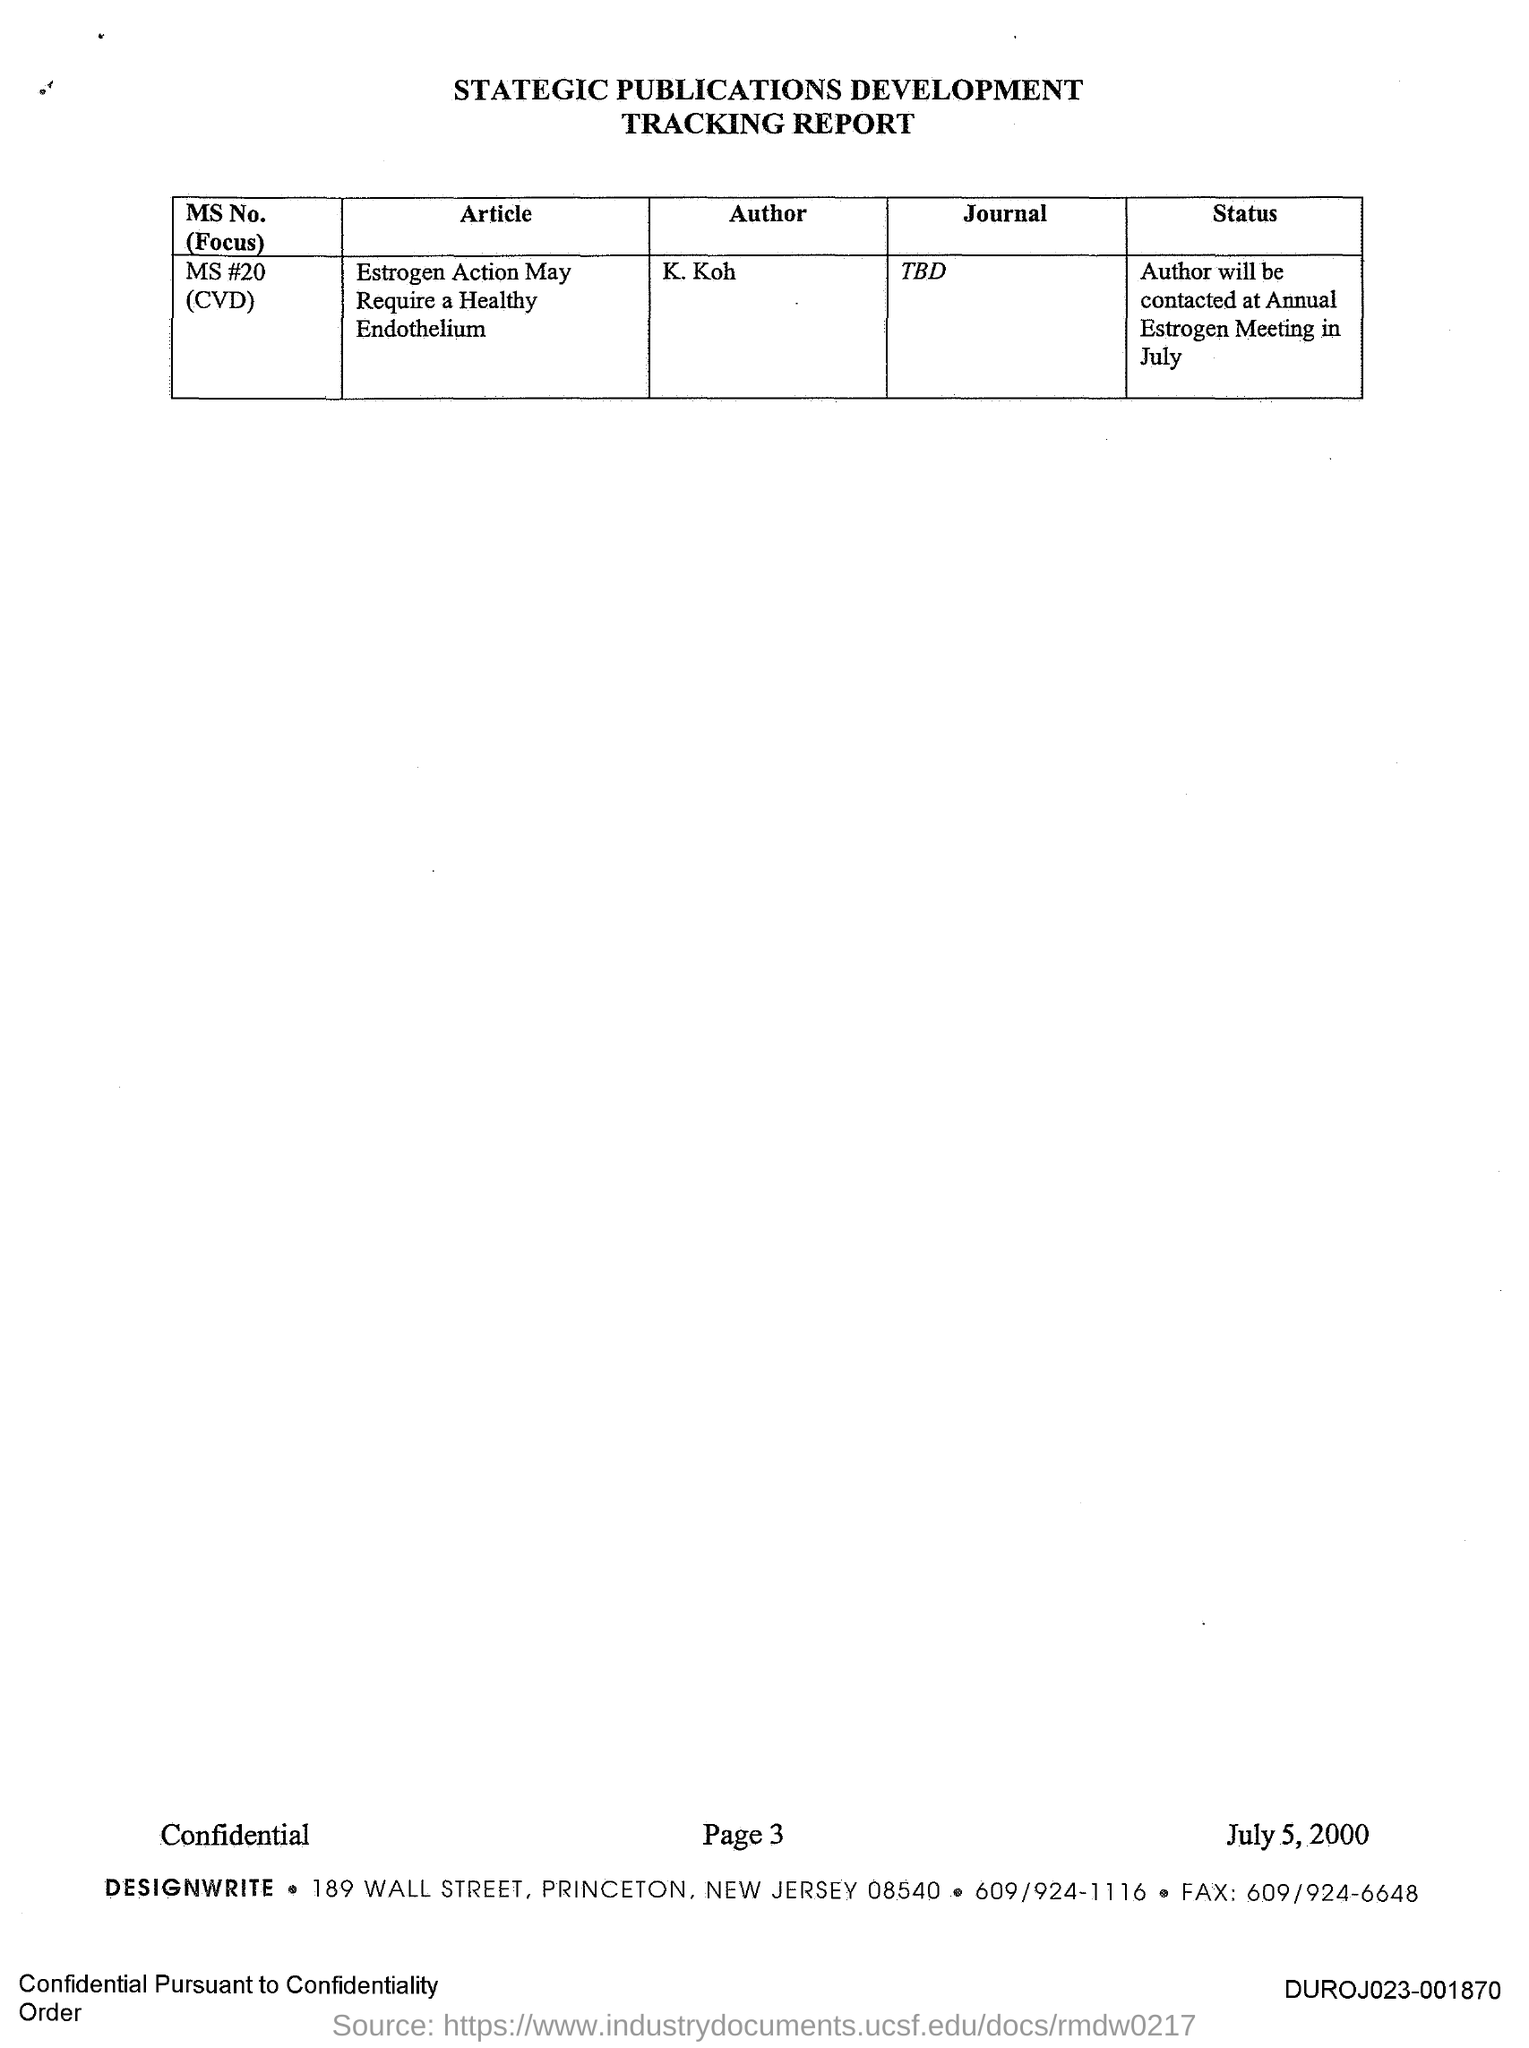K.Koh is the author of which journal?
Your response must be concise. TBD. MS #20 is the ms number of which journal?
Offer a terse response. TBD. 